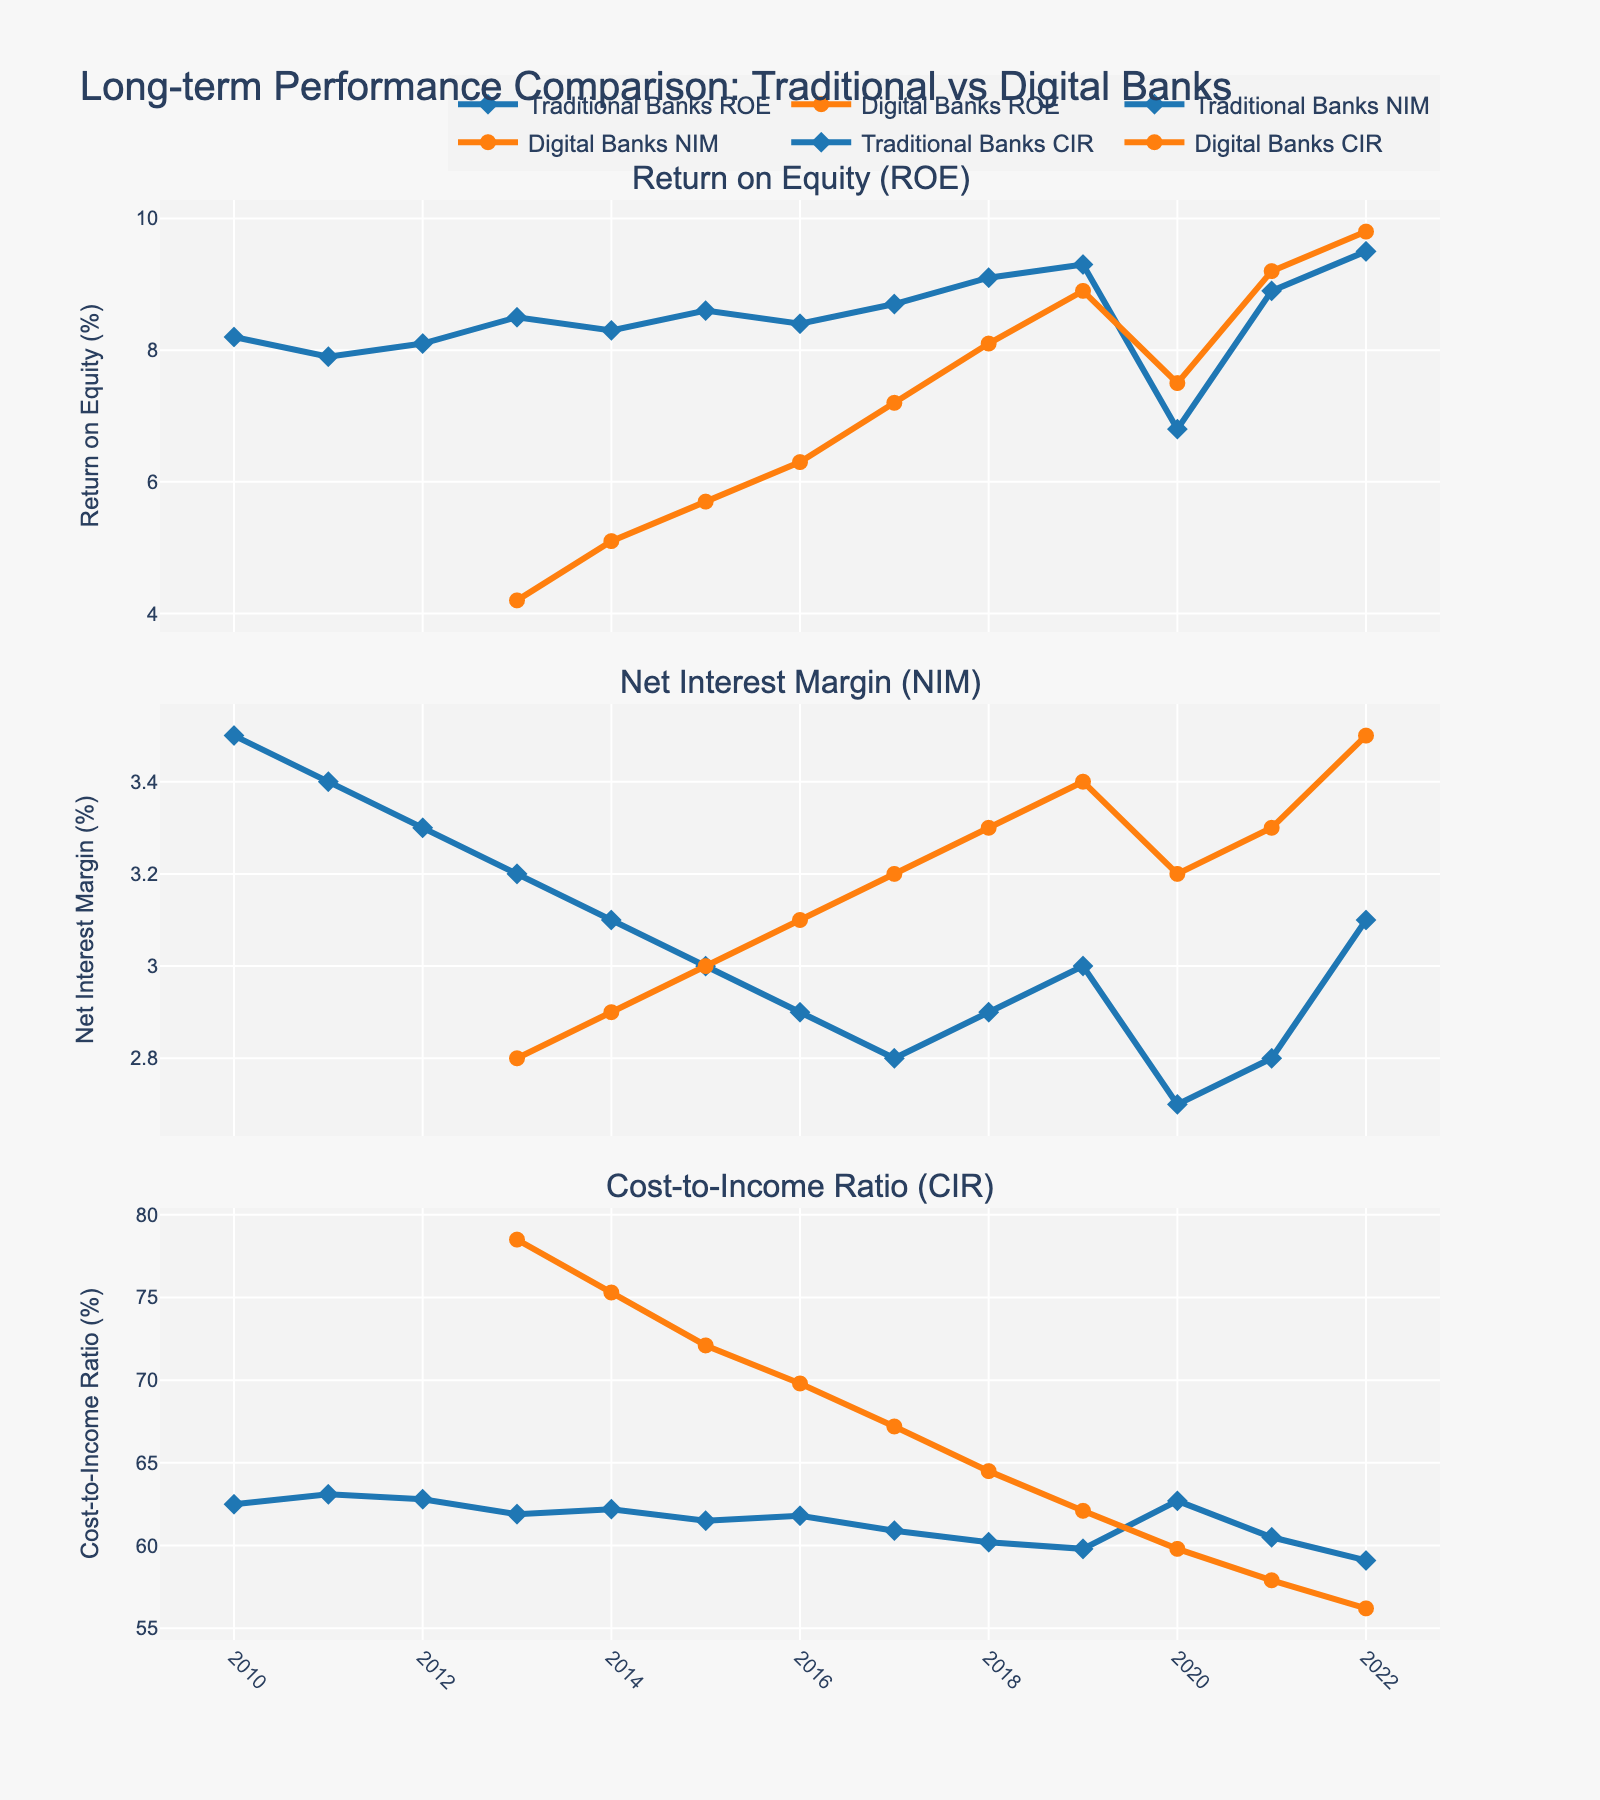What was the highest Return on Equity (ROE) for traditional banks during the timeline? To find the highest Return on Equity (ROE) for traditional banks, we look for the peak value in the `Traditional_Banks_ROE` line. The highest ROE is at the year 2022 with a value of 9.5%.
Answer: 9.5% In which year did digital-only banks have a higher Net Interest Margin (NIM) than traditional banks for the first time? To find the first year digital-only banks surpassed traditional banks in NIM, compare the `Digital_Banks_NIM` and `Traditional_Banks_NIM` lines. The first occurrence is in the year 2017 where digital-only banks had a NIM of 3.2% compared to traditional banks' 2.8%.
Answer: 2017 Which type of bank had a lower Costs-to-Income Ratio (CIR) in 2020, and by how much? To determine which bank had a lower Costs-to-Income Ratio (CIR) in 2020, compare the values from the figure. Traditional banks had a CIR of 62.7%, and digital-only banks had a CIR of 59.8%. The difference is 62.7% - 59.8% = 2.9%. Thus, digital-only banks had a lower CIR by 2.9%.
Answer: Digital-only banks, 2.9% What is the average ROE of digital-only banks from 2013 to 2022? To calculate the average ROE, sum the ROE values of digital-only banks from 2013 (4.2) to 2022 (9.8), then divide by the number of years (10). The sum is 4.2 + 5.1 + 5.7 + 6.3 + 7.2 + 8.1 + 8.9 + 7.5 + 9.2 + 9.8 = 71. Based on 10 years, the average ROE is 71 / 10 = 7.1%.
Answer: 7.1% By how many percentage points did traditional banks' NIM drop from 2010 to 2020? Subtract the NIM value of traditional banks in 2020 from the value in 2010. The NIM was 3.5% in 2010 and 2.7% in 2020. The drop is 3.5% - 2.7% = 0.8 percentage points.
Answer: 0.8% Compare the increase in ROE for both traditional and digital-only banks from 2013 to 2019. Which type of bank had a greater increase, and by how much? Calculate the increase in ROE for each bank type: Traditional banks increased from 8.5% (2013) to 9.3% (2019) which is 9.3% - 8.5% = 0.8%. Digital-only banks increased from 4.2% (2013) to 8.9% (2019) which is 8.9% - 4.2% = 4.7%. Digital-only banks had a greater increase by 4.7% - 0.8% = 3.9%.
Answer: Digital-only banks, 3.9% Which year shows the most significant gap between traditional and digital-only banks' CIR? Examine the CIR lines to find the year with the largest visual separation. The year 2013 shows the most significant gap where traditional banks had a CIR of 61.9% and digital-only banks had a CIR of 78.5%. The difference is 78.5% - 61.9% = 16.6%.
Answer: 2013 Over the plotted years, which year experienced the lowest ROE for either type of bank? Which type was it? Identify the lowest point in the ROE lines for both types of banks. The lowest ROE value is 4.2% for digital-only banks in 2013.
Answer: 2013, digital-only banks 